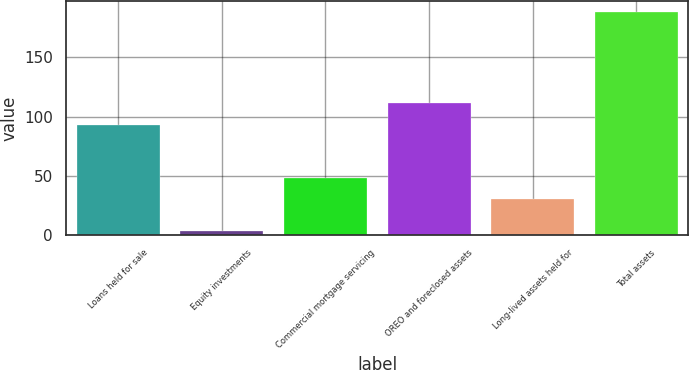<chart> <loc_0><loc_0><loc_500><loc_500><bar_chart><fcel>Loans held for sale<fcel>Equity investments<fcel>Commercial mortgage servicing<fcel>OREO and foreclosed assets<fcel>Long-lived assets held for<fcel>Total assets<nl><fcel>93<fcel>3<fcel>48.5<fcel>111.5<fcel>30<fcel>188<nl></chart> 